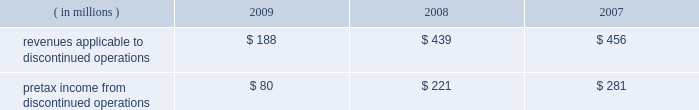Marathon oil corporation notes to consolidated financial statements been reported as discontinued operations in the consolidated statements of income and the consolidated statements of cash flows for all periods presented .
Discontinued operations 2014revenues and pretax income associated with our discontinued irish and gabonese operations are shown in the table : ( in millions ) 2009 2008 2007 .
Angola disposition 2013 in july 2009 , we entered into an agreement to sell an undivided 20 percent outside- operated interest in the production sharing contract and joint operating agreement in block 32 offshore angola for $ 1.3 billion , excluding any purchase price adjustments at closing , with an effective date of january 1 , 2009 .
The sale closed and we received net proceeds of $ 1.3 billion in february 2010 .
The pretax gain on the sale will be approximately $ 800 million .
We retained a 10 percent outside-operated interest in block 32 .
Gabon disposition 2013 in december 2009 , we closed the sale of our operated fields offshore gabon , receiving net proceeds of $ 269 million , after closing adjustments .
A $ 232 million pretax gain on this disposition was reported in discontinued operations for 2009 .
Permian basin disposition 2013 in june 2009 , we closed the sale of our operated and a portion of our outside- operated permian basin producing assets in new mexico and west texas for net proceeds after closing adjustments of $ 293 million .
A $ 196 million pretax gain on the sale was recorded .
Ireland dispositions 2013 in april 2009 , we closed the sale of our operated properties in ireland for net proceeds of $ 84 million , after adjusting for cash held by the sold subsidiary .
A $ 158 million pretax gain on the sale was recorded .
As a result of this sale , we terminated our pension plan in ireland , incurring a charge of $ 18 million .
In june 2009 , we entered into an agreement to sell the subsidiary holding our 19 percent outside-operated interest in the corrib natural gas development offshore ireland .
Total proceeds were estimated to range between $ 235 million and $ 400 million , subject to the timing of first commercial gas at corrib and closing adjustments .
At closing on july 30 , 2009 , the initial $ 100 million payment plus closing adjustments was received .
The fair value of the proceeds was estimated to be $ 311 million .
Fair value of anticipated sale proceeds includes ( i ) $ 100 million received at closing , ( ii ) $ 135 million minimum amount due at the earlier of first gas or december 31 , 2012 , and ( iii ) a range of zero to $ 165 million of contingent proceeds subject to the timing of first commercial gas .
A $ 154 million impairment of the held for sale asset was recognized in discontinued operations in the second quarter of 2009 ( see note 16 ) since the fair value of the disposal group was less than the net book value .
Final proceeds will range between $ 135 million ( minimum amount ) to $ 300 million and are due on the earlier of first commercial gas or december 31 , 2012 .
The fair value of the expected final proceeds was recorded as an asset at closing .
As a result of new public information in the fourth quarter of 2009 , a writeoff was recorded on the contingent portion of the proceeds ( see note 10 ) .
Existing guarantees of our subsidiaries 2019 performance issued to irish government entities will remain in place after the sales until the purchasers issue similar guarantees to replace them .
The guarantees , related to asset retirement obligations and natural gas production levels , have been indemnified by the purchasers .
The fair value of these guarantees is not significant .
Norwegian disposition 2013 on october 31 , 2008 , we closed the sale of our norwegian outside-operated e&p properties and undeveloped offshore acreage in the heimdal area of the norwegian north sea for net proceeds of $ 301 million , with a pretax gain of $ 254 million as of december 31 , 2008 .
Pilot travel centers disposition 2013 on october 8 , 2008 , we completed the sale of our 50 percent ownership interest in ptc .
Sale proceeds were $ 625 million , with a pretax gain on the sale of $ 126 million .
Immediately preceding the sale , we received a $ 75 million partial redemption of our ownership interest from ptc that was accounted for as a return of investment .
This was an investment of our rm&t segment. .
What was total pretax income from discontinued operations for the three year period? 
Computations: table_sum(pretax income from discontinued operations, none)
Answer: 582.0. 